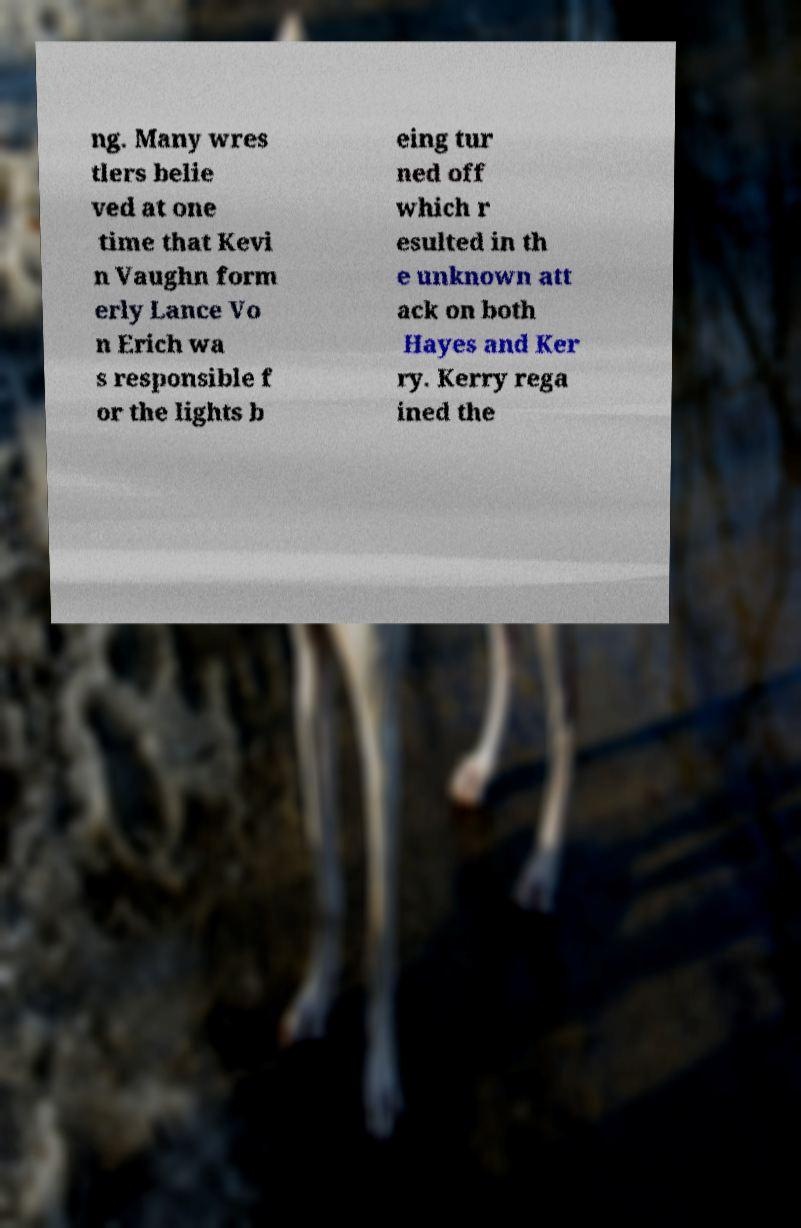Could you extract and type out the text from this image? ng. Many wres tlers belie ved at one time that Kevi n Vaughn form erly Lance Vo n Erich wa s responsible f or the lights b eing tur ned off which r esulted in th e unknown att ack on both Hayes and Ker ry. Kerry rega ined the 